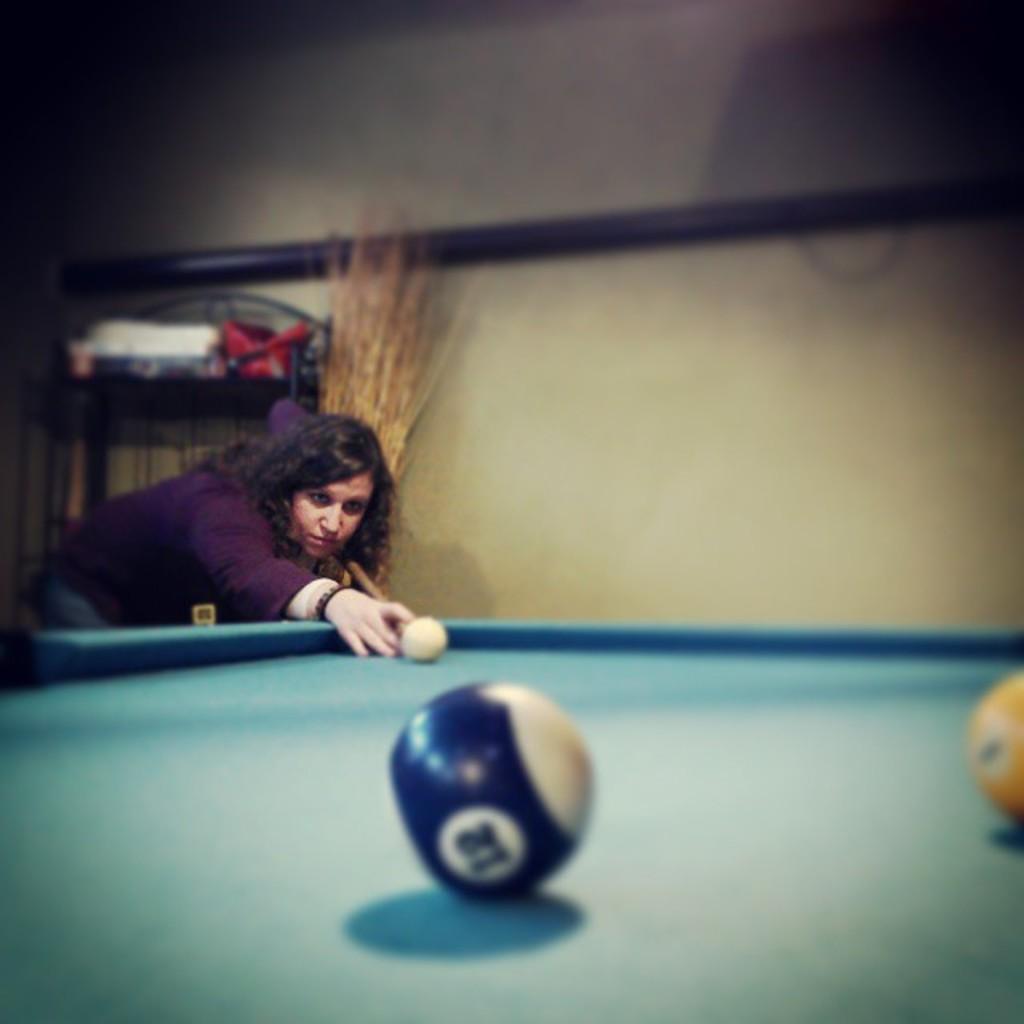Please provide a concise description of this image. In this image we can see a woman holding a stick standing beside the snooker table. We can also see some balls on it. On the backside we can see a table with some objects on it, some kind of fiber, a pole and a wall. 